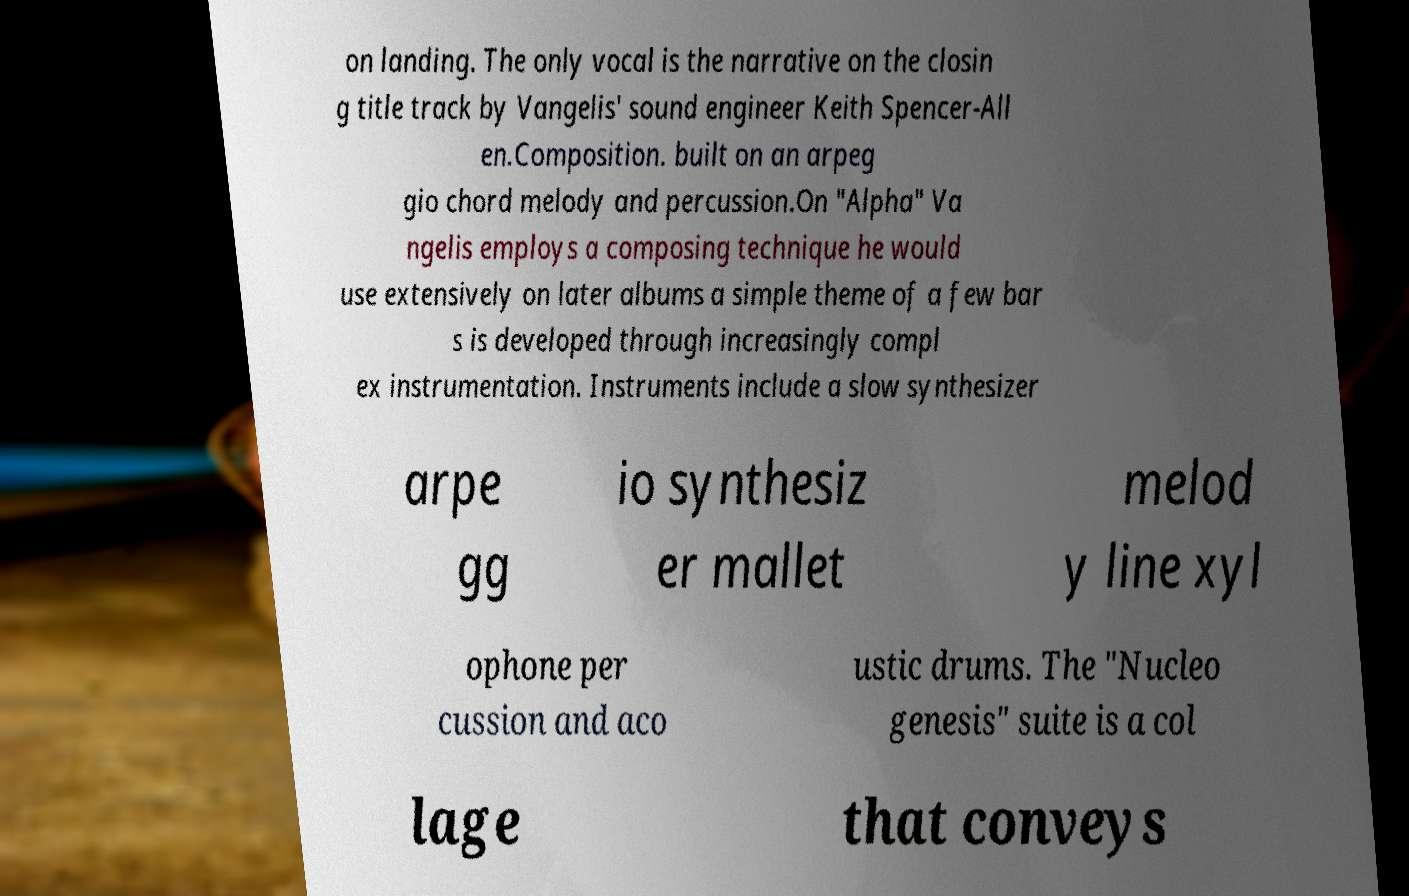Can you accurately transcribe the text from the provided image for me? on landing. The only vocal is the narrative on the closin g title track by Vangelis' sound engineer Keith Spencer-All en.Composition. built on an arpeg gio chord melody and percussion.On "Alpha" Va ngelis employs a composing technique he would use extensively on later albums a simple theme of a few bar s is developed through increasingly compl ex instrumentation. Instruments include a slow synthesizer arpe gg io synthesiz er mallet melod y line xyl ophone per cussion and aco ustic drums. The "Nucleo genesis" suite is a col lage that conveys 